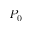Convert formula to latex. <formula><loc_0><loc_0><loc_500><loc_500>P _ { 0 }</formula> 